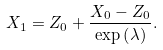Convert formula to latex. <formula><loc_0><loc_0><loc_500><loc_500>X _ { 1 } = Z _ { 0 } + \frac { X _ { 0 } - Z _ { 0 } } { \exp \left ( \lambda \right ) } .</formula> 